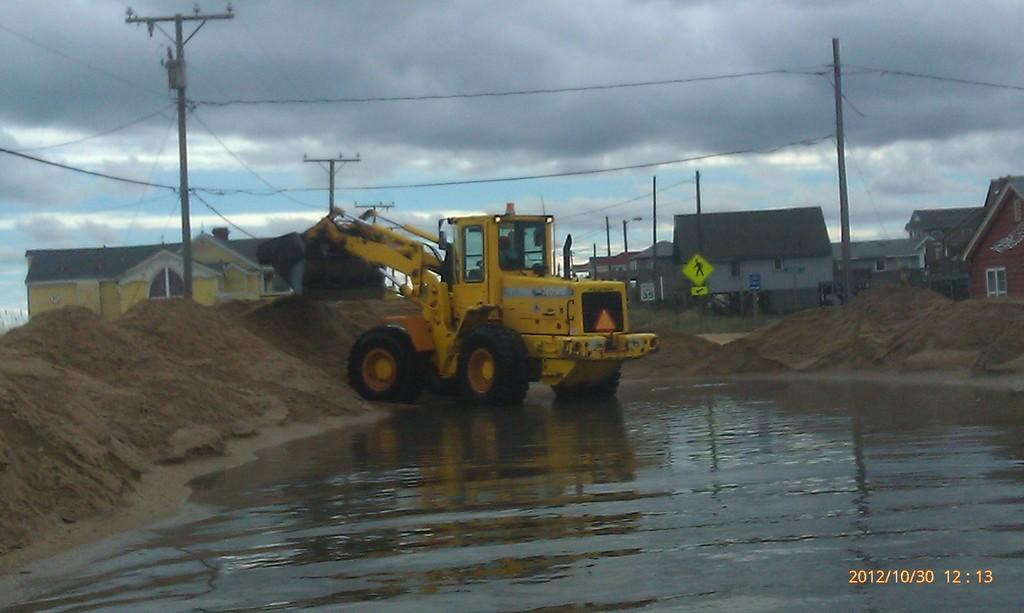Provide a one-sentence caption for the provided image. A tractor moves some dirt on October 30, 2012. 